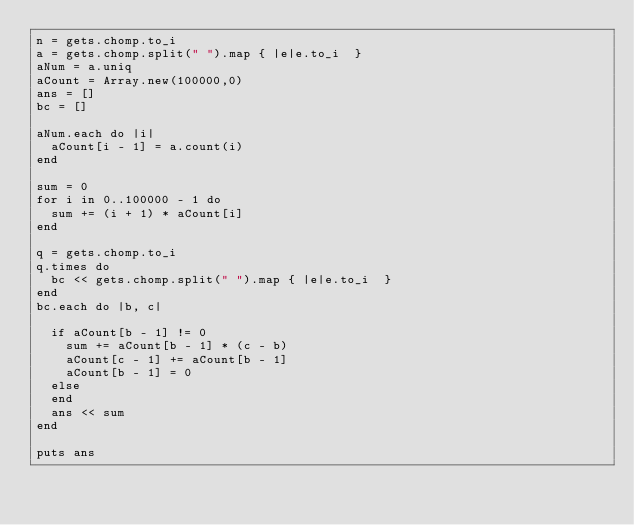Convert code to text. <code><loc_0><loc_0><loc_500><loc_500><_Ruby_>n = gets.chomp.to_i
a = gets.chomp.split(" ").map { |e|e.to_i  }
aNum = a.uniq
aCount = Array.new(100000,0)
ans = []
bc = []

aNum.each do |i|
  aCount[i - 1] = a.count(i)
end

sum = 0
for i in 0..100000 - 1 do
  sum += (i + 1) * aCount[i]
end

q = gets.chomp.to_i
q.times do
  bc << gets.chomp.split(" ").map { |e|e.to_i  }
end
bc.each do |b, c|

  if aCount[b - 1] != 0
    sum += aCount[b - 1] * (c - b)
    aCount[c - 1] += aCount[b - 1]
    aCount[b - 1] = 0
  else
  end
  ans << sum
end

puts ans
</code> 